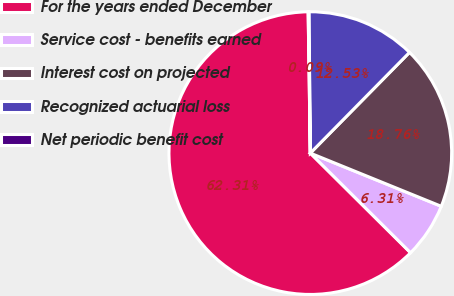Convert chart to OTSL. <chart><loc_0><loc_0><loc_500><loc_500><pie_chart><fcel>For the years ended December<fcel>Service cost - benefits earned<fcel>Interest cost on projected<fcel>Recognized actuarial loss<fcel>Net periodic benefit cost<nl><fcel>62.3%<fcel>6.31%<fcel>18.76%<fcel>12.53%<fcel>0.09%<nl></chart> 